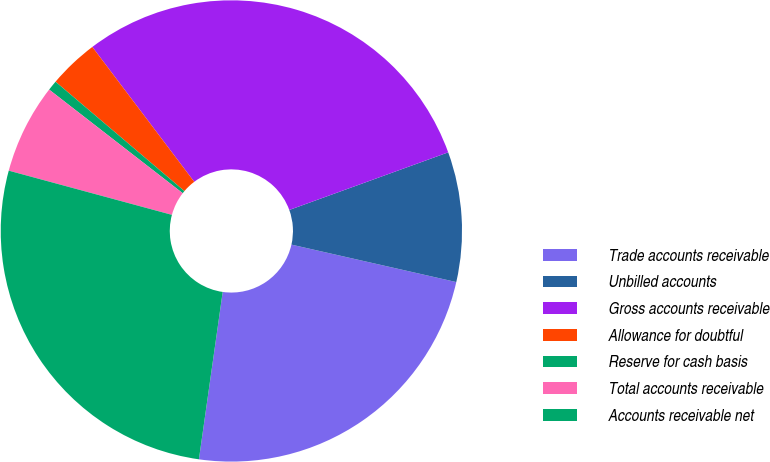Convert chart. <chart><loc_0><loc_0><loc_500><loc_500><pie_chart><fcel>Trade accounts receivable<fcel>Unbilled accounts<fcel>Gross accounts receivable<fcel>Allowance for doubtful<fcel>Reserve for cash basis<fcel>Total accounts receivable<fcel>Accounts receivable net<nl><fcel>23.69%<fcel>9.09%<fcel>29.76%<fcel>3.5%<fcel>0.7%<fcel>6.29%<fcel>26.96%<nl></chart> 